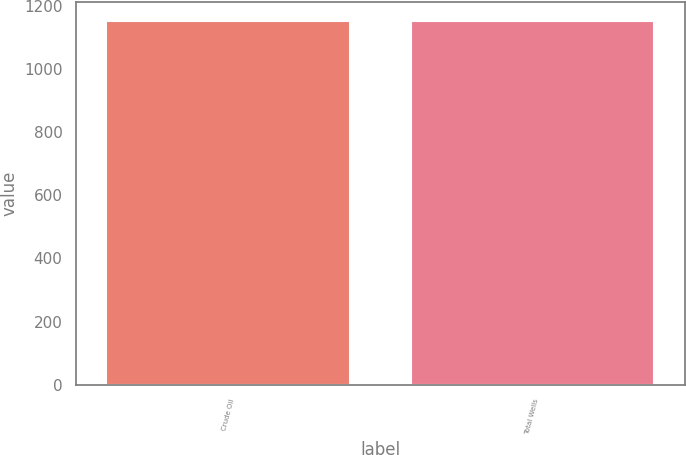<chart> <loc_0><loc_0><loc_500><loc_500><bar_chart><fcel>Crude Oil<fcel>Total Wells<nl><fcel>1152<fcel>1152.1<nl></chart> 